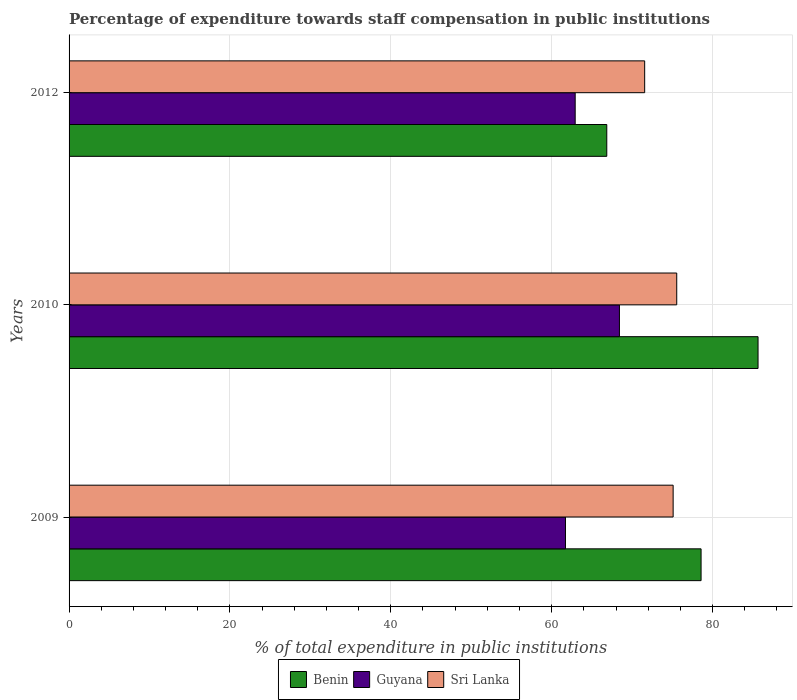How many groups of bars are there?
Provide a succinct answer. 3. Are the number of bars per tick equal to the number of legend labels?
Offer a terse response. Yes. Are the number of bars on each tick of the Y-axis equal?
Your answer should be very brief. Yes. How many bars are there on the 1st tick from the top?
Provide a short and direct response. 3. In how many cases, is the number of bars for a given year not equal to the number of legend labels?
Your response must be concise. 0. What is the percentage of expenditure towards staff compensation in Sri Lanka in 2010?
Provide a succinct answer. 75.55. Across all years, what is the maximum percentage of expenditure towards staff compensation in Benin?
Offer a very short reply. 85.65. Across all years, what is the minimum percentage of expenditure towards staff compensation in Sri Lanka?
Your answer should be very brief. 71.56. What is the total percentage of expenditure towards staff compensation in Guyana in the graph?
Your response must be concise. 193.06. What is the difference between the percentage of expenditure towards staff compensation in Benin in 2010 and that in 2012?
Keep it short and to the point. 18.8. What is the difference between the percentage of expenditure towards staff compensation in Benin in 2010 and the percentage of expenditure towards staff compensation in Guyana in 2009?
Your answer should be compact. 23.94. What is the average percentage of expenditure towards staff compensation in Benin per year?
Give a very brief answer. 77.03. In the year 2012, what is the difference between the percentage of expenditure towards staff compensation in Sri Lanka and percentage of expenditure towards staff compensation in Guyana?
Offer a very short reply. 8.64. In how many years, is the percentage of expenditure towards staff compensation in Sri Lanka greater than 40 %?
Give a very brief answer. 3. What is the ratio of the percentage of expenditure towards staff compensation in Sri Lanka in 2010 to that in 2012?
Offer a terse response. 1.06. Is the percentage of expenditure towards staff compensation in Sri Lanka in 2010 less than that in 2012?
Your response must be concise. No. What is the difference between the highest and the second highest percentage of expenditure towards staff compensation in Guyana?
Keep it short and to the point. 5.5. What is the difference between the highest and the lowest percentage of expenditure towards staff compensation in Benin?
Ensure brevity in your answer.  18.8. Is the sum of the percentage of expenditure towards staff compensation in Benin in 2009 and 2010 greater than the maximum percentage of expenditure towards staff compensation in Guyana across all years?
Give a very brief answer. Yes. What does the 2nd bar from the top in 2010 represents?
Your answer should be compact. Guyana. What does the 2nd bar from the bottom in 2009 represents?
Make the answer very short. Guyana. Is it the case that in every year, the sum of the percentage of expenditure towards staff compensation in Guyana and percentage of expenditure towards staff compensation in Benin is greater than the percentage of expenditure towards staff compensation in Sri Lanka?
Ensure brevity in your answer.  Yes. How many bars are there?
Your answer should be very brief. 9. Are all the bars in the graph horizontal?
Offer a very short reply. Yes. How many years are there in the graph?
Your answer should be very brief. 3. Where does the legend appear in the graph?
Your answer should be compact. Bottom center. What is the title of the graph?
Your answer should be compact. Percentage of expenditure towards staff compensation in public institutions. Does "Micronesia" appear as one of the legend labels in the graph?
Provide a succinct answer. No. What is the label or title of the X-axis?
Make the answer very short. % of total expenditure in public institutions. What is the label or title of the Y-axis?
Make the answer very short. Years. What is the % of total expenditure in public institutions of Benin in 2009?
Offer a very short reply. 78.57. What is the % of total expenditure in public institutions of Guyana in 2009?
Keep it short and to the point. 61.71. What is the % of total expenditure in public institutions of Sri Lanka in 2009?
Keep it short and to the point. 75.1. What is the % of total expenditure in public institutions of Benin in 2010?
Give a very brief answer. 85.65. What is the % of total expenditure in public institutions of Guyana in 2010?
Your answer should be compact. 68.42. What is the % of total expenditure in public institutions of Sri Lanka in 2010?
Offer a terse response. 75.55. What is the % of total expenditure in public institutions of Benin in 2012?
Offer a terse response. 66.85. What is the % of total expenditure in public institutions of Guyana in 2012?
Provide a succinct answer. 62.92. What is the % of total expenditure in public institutions of Sri Lanka in 2012?
Your response must be concise. 71.56. Across all years, what is the maximum % of total expenditure in public institutions of Benin?
Keep it short and to the point. 85.65. Across all years, what is the maximum % of total expenditure in public institutions in Guyana?
Offer a very short reply. 68.42. Across all years, what is the maximum % of total expenditure in public institutions in Sri Lanka?
Your response must be concise. 75.55. Across all years, what is the minimum % of total expenditure in public institutions of Benin?
Ensure brevity in your answer.  66.85. Across all years, what is the minimum % of total expenditure in public institutions of Guyana?
Offer a terse response. 61.71. Across all years, what is the minimum % of total expenditure in public institutions of Sri Lanka?
Make the answer very short. 71.56. What is the total % of total expenditure in public institutions in Benin in the graph?
Provide a succinct answer. 231.08. What is the total % of total expenditure in public institutions in Guyana in the graph?
Ensure brevity in your answer.  193.06. What is the total % of total expenditure in public institutions of Sri Lanka in the graph?
Offer a terse response. 222.2. What is the difference between the % of total expenditure in public institutions in Benin in 2009 and that in 2010?
Your answer should be compact. -7.08. What is the difference between the % of total expenditure in public institutions of Guyana in 2009 and that in 2010?
Your answer should be very brief. -6.71. What is the difference between the % of total expenditure in public institutions in Sri Lanka in 2009 and that in 2010?
Make the answer very short. -0.45. What is the difference between the % of total expenditure in public institutions in Benin in 2009 and that in 2012?
Offer a very short reply. 11.72. What is the difference between the % of total expenditure in public institutions of Guyana in 2009 and that in 2012?
Provide a short and direct response. -1.21. What is the difference between the % of total expenditure in public institutions in Sri Lanka in 2009 and that in 2012?
Provide a short and direct response. 3.54. What is the difference between the % of total expenditure in public institutions of Benin in 2010 and that in 2012?
Offer a terse response. 18.8. What is the difference between the % of total expenditure in public institutions in Guyana in 2010 and that in 2012?
Your response must be concise. 5.5. What is the difference between the % of total expenditure in public institutions of Sri Lanka in 2010 and that in 2012?
Ensure brevity in your answer.  3.99. What is the difference between the % of total expenditure in public institutions in Benin in 2009 and the % of total expenditure in public institutions in Guyana in 2010?
Make the answer very short. 10.15. What is the difference between the % of total expenditure in public institutions in Benin in 2009 and the % of total expenditure in public institutions in Sri Lanka in 2010?
Provide a succinct answer. 3.03. What is the difference between the % of total expenditure in public institutions of Guyana in 2009 and the % of total expenditure in public institutions of Sri Lanka in 2010?
Provide a short and direct response. -13.83. What is the difference between the % of total expenditure in public institutions in Benin in 2009 and the % of total expenditure in public institutions in Guyana in 2012?
Your response must be concise. 15.65. What is the difference between the % of total expenditure in public institutions in Benin in 2009 and the % of total expenditure in public institutions in Sri Lanka in 2012?
Keep it short and to the point. 7.01. What is the difference between the % of total expenditure in public institutions in Guyana in 2009 and the % of total expenditure in public institutions in Sri Lanka in 2012?
Ensure brevity in your answer.  -9.85. What is the difference between the % of total expenditure in public institutions of Benin in 2010 and the % of total expenditure in public institutions of Guyana in 2012?
Your answer should be very brief. 22.73. What is the difference between the % of total expenditure in public institutions of Benin in 2010 and the % of total expenditure in public institutions of Sri Lanka in 2012?
Your response must be concise. 14.09. What is the difference between the % of total expenditure in public institutions of Guyana in 2010 and the % of total expenditure in public institutions of Sri Lanka in 2012?
Provide a short and direct response. -3.14. What is the average % of total expenditure in public institutions in Benin per year?
Ensure brevity in your answer.  77.03. What is the average % of total expenditure in public institutions of Guyana per year?
Offer a very short reply. 64.35. What is the average % of total expenditure in public institutions of Sri Lanka per year?
Your answer should be compact. 74.07. In the year 2009, what is the difference between the % of total expenditure in public institutions in Benin and % of total expenditure in public institutions in Guyana?
Give a very brief answer. 16.86. In the year 2009, what is the difference between the % of total expenditure in public institutions of Benin and % of total expenditure in public institutions of Sri Lanka?
Your answer should be very brief. 3.47. In the year 2009, what is the difference between the % of total expenditure in public institutions in Guyana and % of total expenditure in public institutions in Sri Lanka?
Offer a terse response. -13.38. In the year 2010, what is the difference between the % of total expenditure in public institutions in Benin and % of total expenditure in public institutions in Guyana?
Your answer should be very brief. 17.23. In the year 2010, what is the difference between the % of total expenditure in public institutions in Benin and % of total expenditure in public institutions in Sri Lanka?
Provide a succinct answer. 10.11. In the year 2010, what is the difference between the % of total expenditure in public institutions of Guyana and % of total expenditure in public institutions of Sri Lanka?
Your response must be concise. -7.12. In the year 2012, what is the difference between the % of total expenditure in public institutions of Benin and % of total expenditure in public institutions of Guyana?
Offer a terse response. 3.93. In the year 2012, what is the difference between the % of total expenditure in public institutions in Benin and % of total expenditure in public institutions in Sri Lanka?
Offer a terse response. -4.71. In the year 2012, what is the difference between the % of total expenditure in public institutions in Guyana and % of total expenditure in public institutions in Sri Lanka?
Ensure brevity in your answer.  -8.64. What is the ratio of the % of total expenditure in public institutions of Benin in 2009 to that in 2010?
Ensure brevity in your answer.  0.92. What is the ratio of the % of total expenditure in public institutions in Guyana in 2009 to that in 2010?
Make the answer very short. 0.9. What is the ratio of the % of total expenditure in public institutions of Sri Lanka in 2009 to that in 2010?
Offer a very short reply. 0.99. What is the ratio of the % of total expenditure in public institutions of Benin in 2009 to that in 2012?
Offer a very short reply. 1.18. What is the ratio of the % of total expenditure in public institutions in Guyana in 2009 to that in 2012?
Provide a succinct answer. 0.98. What is the ratio of the % of total expenditure in public institutions in Sri Lanka in 2009 to that in 2012?
Offer a terse response. 1.05. What is the ratio of the % of total expenditure in public institutions in Benin in 2010 to that in 2012?
Give a very brief answer. 1.28. What is the ratio of the % of total expenditure in public institutions in Guyana in 2010 to that in 2012?
Give a very brief answer. 1.09. What is the ratio of the % of total expenditure in public institutions of Sri Lanka in 2010 to that in 2012?
Your response must be concise. 1.06. What is the difference between the highest and the second highest % of total expenditure in public institutions of Benin?
Offer a very short reply. 7.08. What is the difference between the highest and the second highest % of total expenditure in public institutions in Guyana?
Your answer should be very brief. 5.5. What is the difference between the highest and the second highest % of total expenditure in public institutions in Sri Lanka?
Make the answer very short. 0.45. What is the difference between the highest and the lowest % of total expenditure in public institutions of Benin?
Make the answer very short. 18.8. What is the difference between the highest and the lowest % of total expenditure in public institutions of Guyana?
Offer a very short reply. 6.71. What is the difference between the highest and the lowest % of total expenditure in public institutions of Sri Lanka?
Ensure brevity in your answer.  3.99. 